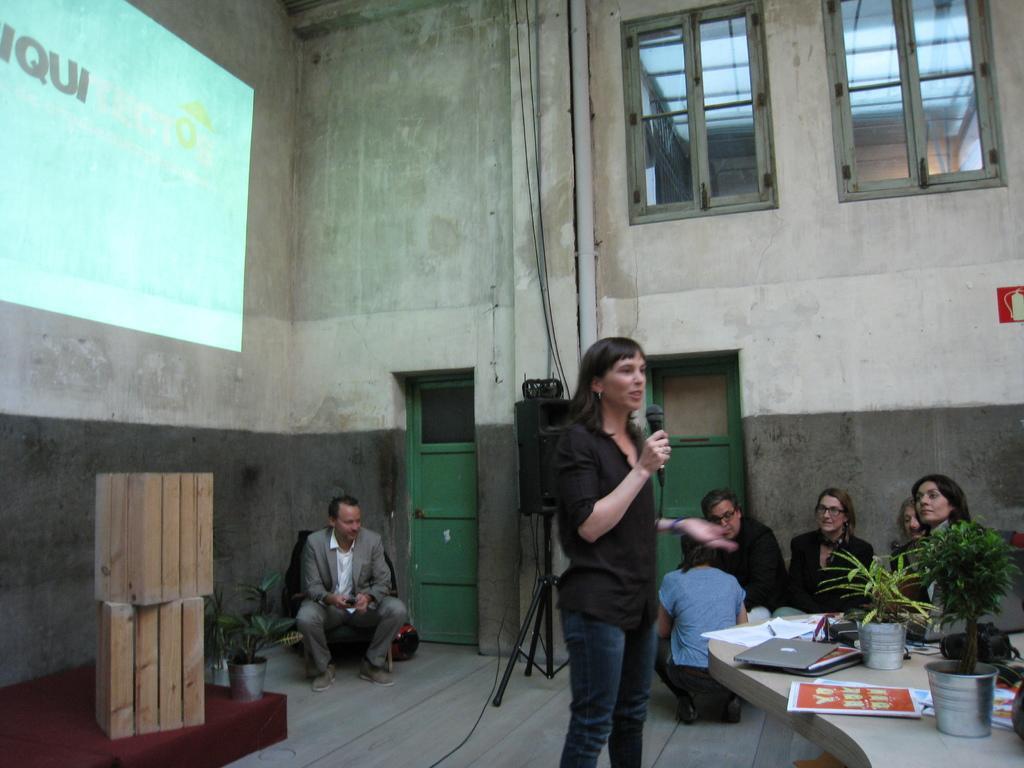Please provide a concise description of this image. In this image I can see a woman standing and holding a microphone. There are plant pots, laptop and papers on a table, on the right side. People are sitting at the back. There is a projector display on the left and there are 2 wooden boxes. There is a building at the back which has a pipe, 2 green doors and window at the top. 